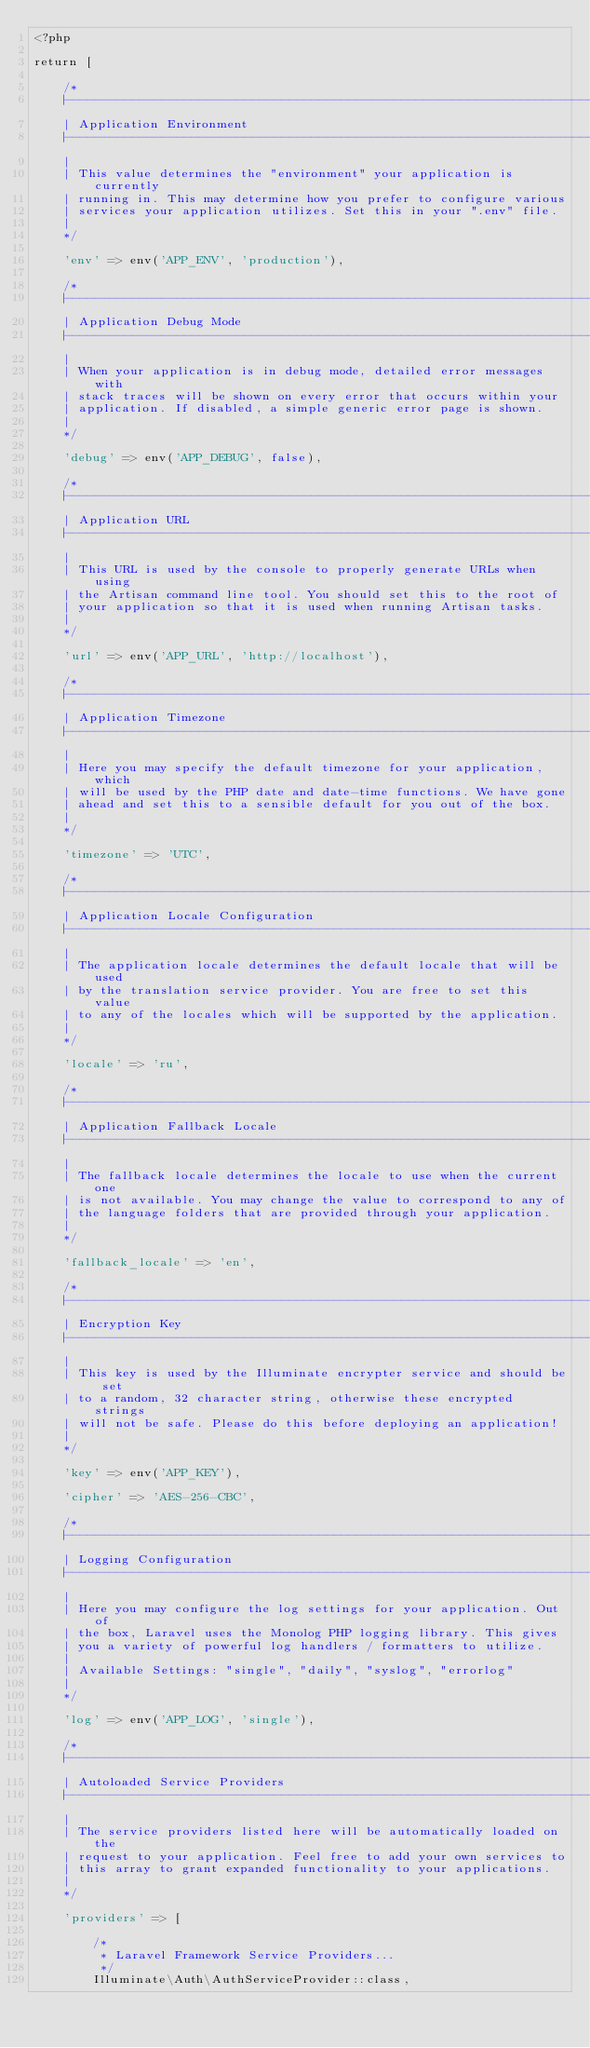Convert code to text. <code><loc_0><loc_0><loc_500><loc_500><_PHP_><?php

return [

    /*
    |--------------------------------------------------------------------------
    | Application Environment
    |--------------------------------------------------------------------------
    |
    | This value determines the "environment" your application is currently
    | running in. This may determine how you prefer to configure various
    | services your application utilizes. Set this in your ".env" file.
    |
    */

    'env' => env('APP_ENV', 'production'),

    /*
    |--------------------------------------------------------------------------
    | Application Debug Mode
    |--------------------------------------------------------------------------
    |
    | When your application is in debug mode, detailed error messages with
    | stack traces will be shown on every error that occurs within your
    | application. If disabled, a simple generic error page is shown.
    |
    */

    'debug' => env('APP_DEBUG', false),

    /*
    |--------------------------------------------------------------------------
    | Application URL
    |--------------------------------------------------------------------------
    |
    | This URL is used by the console to properly generate URLs when using
    | the Artisan command line tool. You should set this to the root of
    | your application so that it is used when running Artisan tasks.
    |
    */

    'url' => env('APP_URL', 'http://localhost'),

    /*
    |--------------------------------------------------------------------------
    | Application Timezone
    |--------------------------------------------------------------------------
    |
    | Here you may specify the default timezone for your application, which
    | will be used by the PHP date and date-time functions. We have gone
    | ahead and set this to a sensible default for you out of the box.
    |
    */

    'timezone' => 'UTC',

    /*
    |--------------------------------------------------------------------------
    | Application Locale Configuration
    |--------------------------------------------------------------------------
    |
    | The application locale determines the default locale that will be used
    | by the translation service provider. You are free to set this value
    | to any of the locales which will be supported by the application.
    |
    */

    'locale' => 'ru',

    /*
    |--------------------------------------------------------------------------
    | Application Fallback Locale
    |--------------------------------------------------------------------------
    |
    | The fallback locale determines the locale to use when the current one
    | is not available. You may change the value to correspond to any of
    | the language folders that are provided through your application.
    |
    */

    'fallback_locale' => 'en',

    /*
    |--------------------------------------------------------------------------
    | Encryption Key
    |--------------------------------------------------------------------------
    |
    | This key is used by the Illuminate encrypter service and should be set
    | to a random, 32 character string, otherwise these encrypted strings
    | will not be safe. Please do this before deploying an application!
    |
    */

    'key' => env('APP_KEY'),

    'cipher' => 'AES-256-CBC',

    /*
    |--------------------------------------------------------------------------
    | Logging Configuration
    |--------------------------------------------------------------------------
    |
    | Here you may configure the log settings for your application. Out of
    | the box, Laravel uses the Monolog PHP logging library. This gives
    | you a variety of powerful log handlers / formatters to utilize.
    |
    | Available Settings: "single", "daily", "syslog", "errorlog"
    |
    */

    'log' => env('APP_LOG', 'single'),

    /*
    |--------------------------------------------------------------------------
    | Autoloaded Service Providers
    |--------------------------------------------------------------------------
    |
    | The service providers listed here will be automatically loaded on the
    | request to your application. Feel free to add your own services to
    | this array to grant expanded functionality to your applications.
    |
    */

    'providers' => [

        /*
         * Laravel Framework Service Providers...
         */
        Illuminate\Auth\AuthServiceProvider::class,</code> 